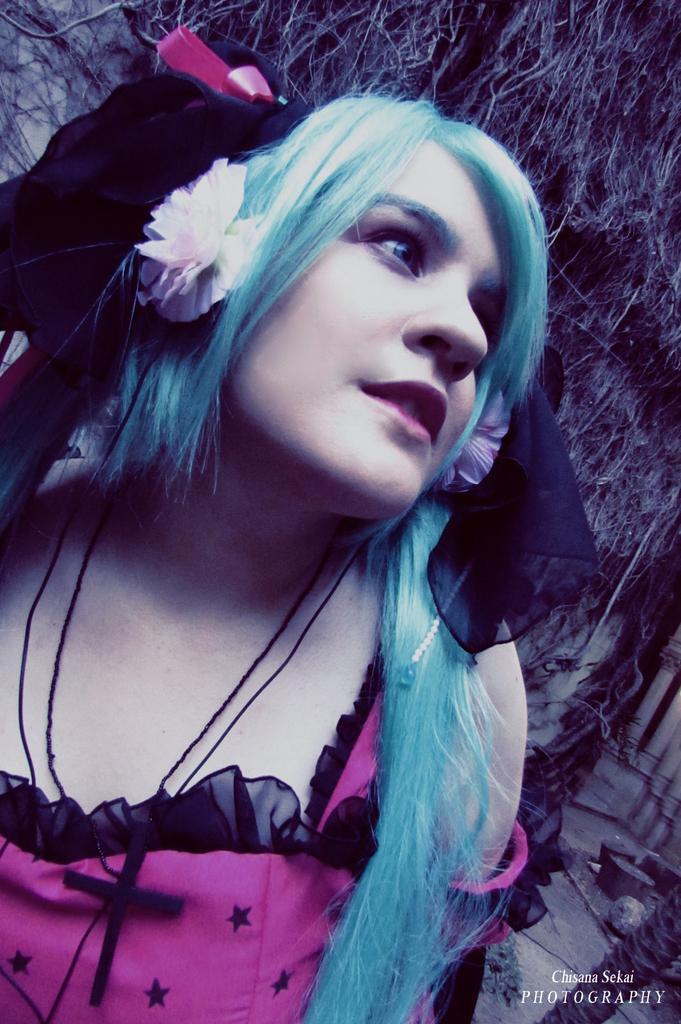Describe this image in one or two sentences. In this image there is a woman. 